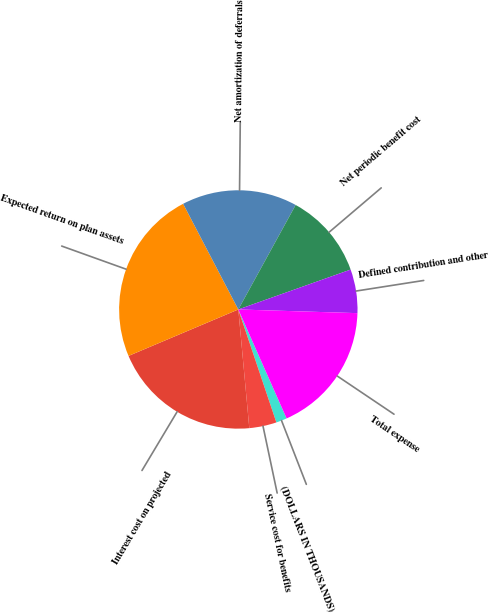Convert chart to OTSL. <chart><loc_0><loc_0><loc_500><loc_500><pie_chart><fcel>(DOLLARS IN THOUSANDS)<fcel>Service cost for benefits<fcel>Interest cost on projected<fcel>Expected return on plan assets<fcel>Net amortization of deferrals<fcel>Net periodic benefit cost<fcel>Defined contribution and other<fcel>Total expense<nl><fcel>1.47%<fcel>3.7%<fcel>20.1%<fcel>23.71%<fcel>15.65%<fcel>11.58%<fcel>5.92%<fcel>17.87%<nl></chart> 